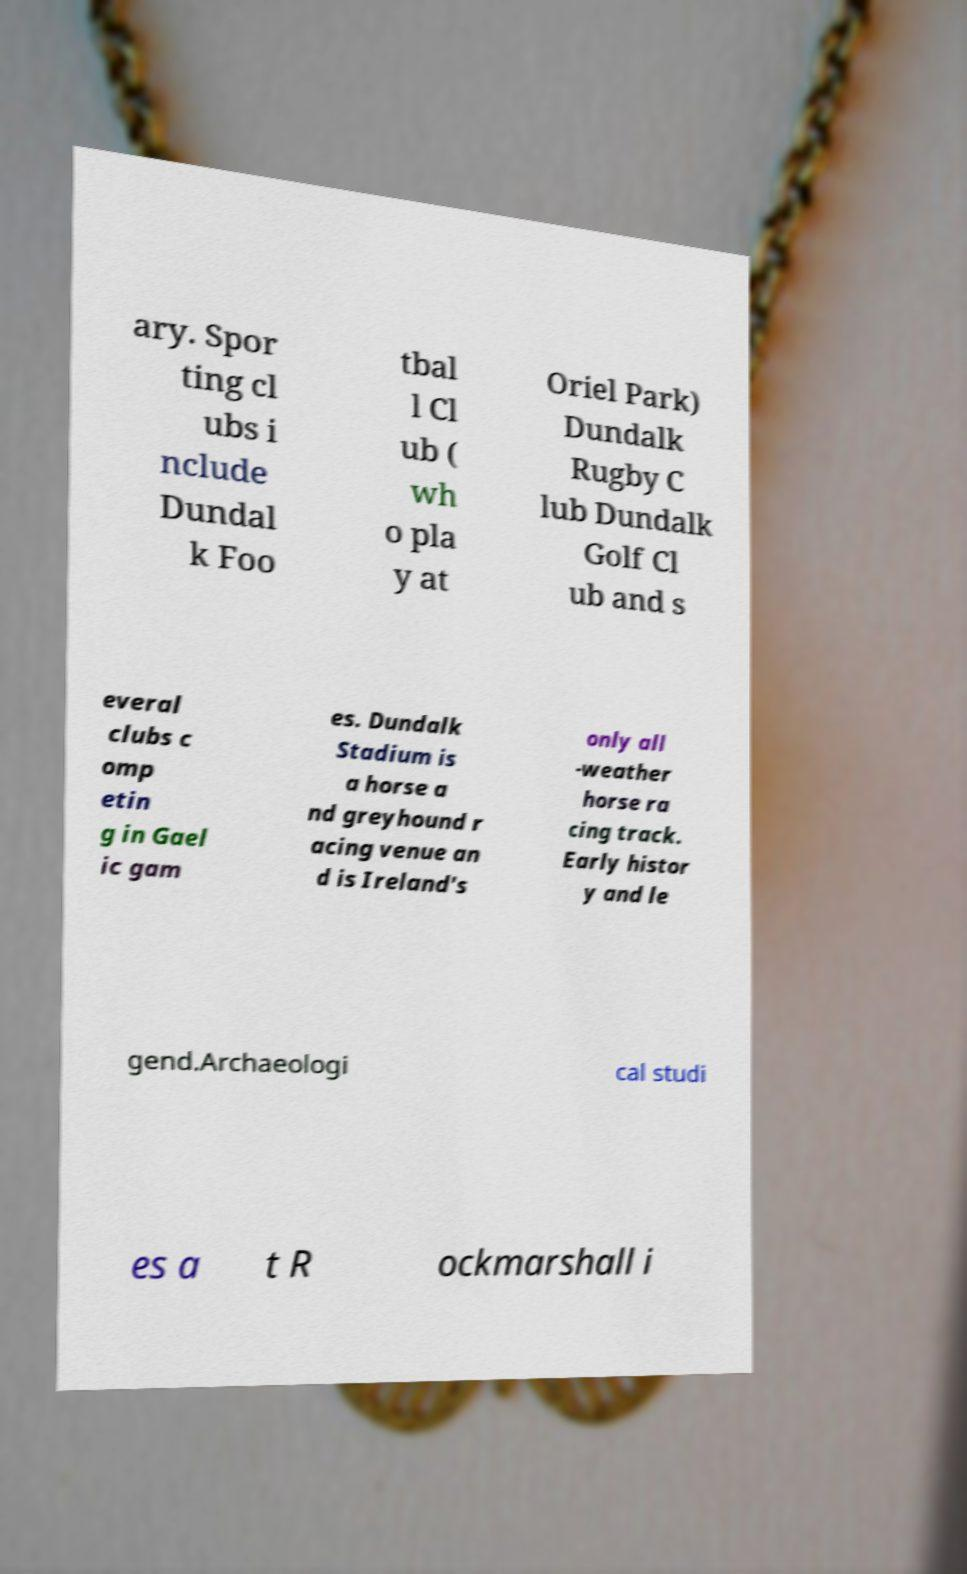What messages or text are displayed in this image? I need them in a readable, typed format. ary. Spor ting cl ubs i nclude Dundal k Foo tbal l Cl ub ( wh o pla y at Oriel Park) Dundalk Rugby C lub Dundalk Golf Cl ub and s everal clubs c omp etin g in Gael ic gam es. Dundalk Stadium is a horse a nd greyhound r acing venue an d is Ireland's only all -weather horse ra cing track. Early histor y and le gend.Archaeologi cal studi es a t R ockmarshall i 